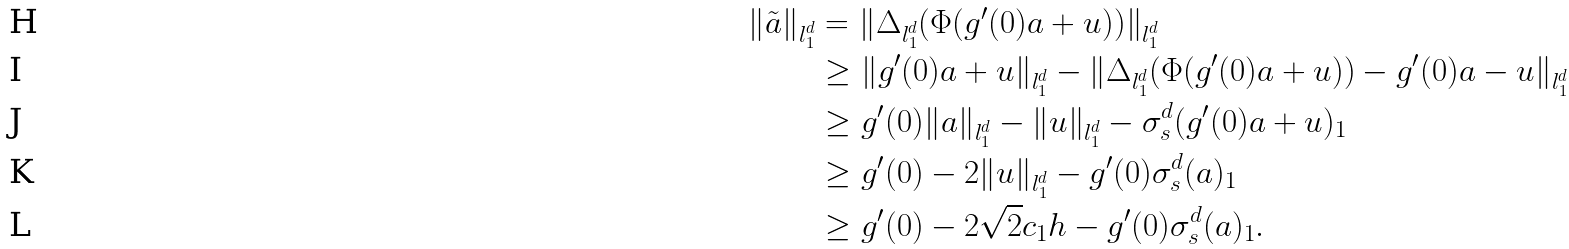Convert formula to latex. <formula><loc_0><loc_0><loc_500><loc_500>\| \tilde { a } \| _ { l _ { 1 } ^ { d } } & = \| \Delta _ { l _ { 1 } ^ { d } } ( \Phi ( g ^ { \prime } ( 0 ) a + u ) ) \| _ { l _ { 1 } ^ { d } } \\ & \geq \| g ^ { \prime } ( 0 ) a + u \| _ { l _ { 1 } ^ { d } } - \| \Delta _ { l _ { 1 } ^ { d } } ( \Phi ( g ^ { \prime } ( 0 ) a + u ) ) - g ^ { \prime } ( 0 ) a - u \| _ { l _ { 1 } ^ { d } } \\ & \geq g ^ { \prime } ( 0 ) \| a \| _ { l _ { 1 } ^ { d } } - \| u \| _ { l _ { 1 } ^ { d } } - \sigma _ { s } ^ { d } ( g ^ { \prime } ( 0 ) a + u ) _ { 1 } \\ & \geq g ^ { \prime } ( 0 ) - 2 \| u \| _ { l _ { 1 } ^ { d } } - g ^ { \prime } ( 0 ) \sigma _ { s } ^ { d } ( a ) _ { 1 } \\ & \geq g ^ { \prime } ( 0 ) - 2 \sqrt { 2 } c _ { 1 } h - g ^ { \prime } ( 0 ) \sigma _ { s } ^ { d } ( a ) _ { 1 } .</formula> 